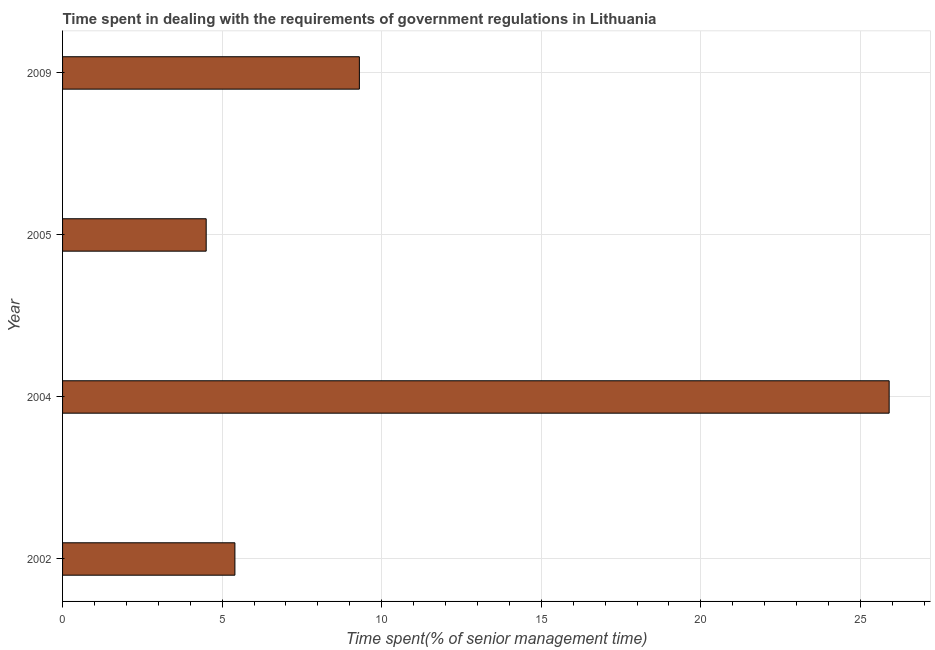Does the graph contain any zero values?
Your answer should be compact. No. Does the graph contain grids?
Keep it short and to the point. Yes. What is the title of the graph?
Ensure brevity in your answer.  Time spent in dealing with the requirements of government regulations in Lithuania. What is the label or title of the X-axis?
Provide a succinct answer. Time spent(% of senior management time). Across all years, what is the maximum time spent in dealing with government regulations?
Your answer should be compact. 25.9. In which year was the time spent in dealing with government regulations maximum?
Provide a short and direct response. 2004. In which year was the time spent in dealing with government regulations minimum?
Your response must be concise. 2005. What is the sum of the time spent in dealing with government regulations?
Ensure brevity in your answer.  45.1. What is the difference between the time spent in dealing with government regulations in 2005 and 2009?
Provide a succinct answer. -4.8. What is the average time spent in dealing with government regulations per year?
Keep it short and to the point. 11.28. What is the median time spent in dealing with government regulations?
Offer a terse response. 7.35. In how many years, is the time spent in dealing with government regulations greater than 21 %?
Provide a succinct answer. 1. Do a majority of the years between 2002 and 2009 (inclusive) have time spent in dealing with government regulations greater than 4 %?
Keep it short and to the point. Yes. What is the ratio of the time spent in dealing with government regulations in 2004 to that in 2005?
Provide a succinct answer. 5.76. What is the difference between the highest and the lowest time spent in dealing with government regulations?
Your answer should be very brief. 21.4. How many years are there in the graph?
Offer a terse response. 4. What is the difference between two consecutive major ticks on the X-axis?
Provide a short and direct response. 5. What is the Time spent(% of senior management time) of 2002?
Offer a very short reply. 5.4. What is the Time spent(% of senior management time) of 2004?
Give a very brief answer. 25.9. What is the Time spent(% of senior management time) in 2009?
Your response must be concise. 9.3. What is the difference between the Time spent(% of senior management time) in 2002 and 2004?
Your response must be concise. -20.5. What is the difference between the Time spent(% of senior management time) in 2002 and 2009?
Ensure brevity in your answer.  -3.9. What is the difference between the Time spent(% of senior management time) in 2004 and 2005?
Ensure brevity in your answer.  21.4. What is the ratio of the Time spent(% of senior management time) in 2002 to that in 2004?
Keep it short and to the point. 0.21. What is the ratio of the Time spent(% of senior management time) in 2002 to that in 2005?
Provide a short and direct response. 1.2. What is the ratio of the Time spent(% of senior management time) in 2002 to that in 2009?
Ensure brevity in your answer.  0.58. What is the ratio of the Time spent(% of senior management time) in 2004 to that in 2005?
Give a very brief answer. 5.76. What is the ratio of the Time spent(% of senior management time) in 2004 to that in 2009?
Offer a very short reply. 2.79. What is the ratio of the Time spent(% of senior management time) in 2005 to that in 2009?
Keep it short and to the point. 0.48. 